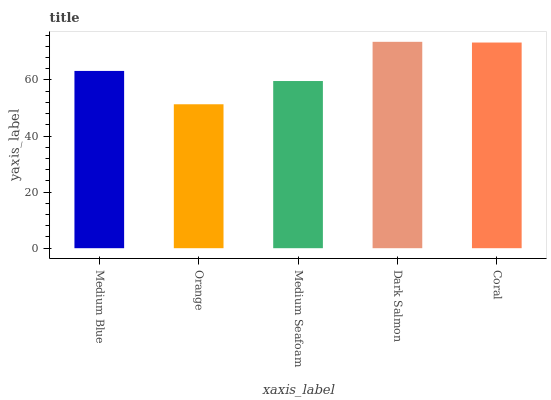Is Orange the minimum?
Answer yes or no. Yes. Is Dark Salmon the maximum?
Answer yes or no. Yes. Is Medium Seafoam the minimum?
Answer yes or no. No. Is Medium Seafoam the maximum?
Answer yes or no. No. Is Medium Seafoam greater than Orange?
Answer yes or no. Yes. Is Orange less than Medium Seafoam?
Answer yes or no. Yes. Is Orange greater than Medium Seafoam?
Answer yes or no. No. Is Medium Seafoam less than Orange?
Answer yes or no. No. Is Medium Blue the high median?
Answer yes or no. Yes. Is Medium Blue the low median?
Answer yes or no. Yes. Is Dark Salmon the high median?
Answer yes or no. No. Is Orange the low median?
Answer yes or no. No. 